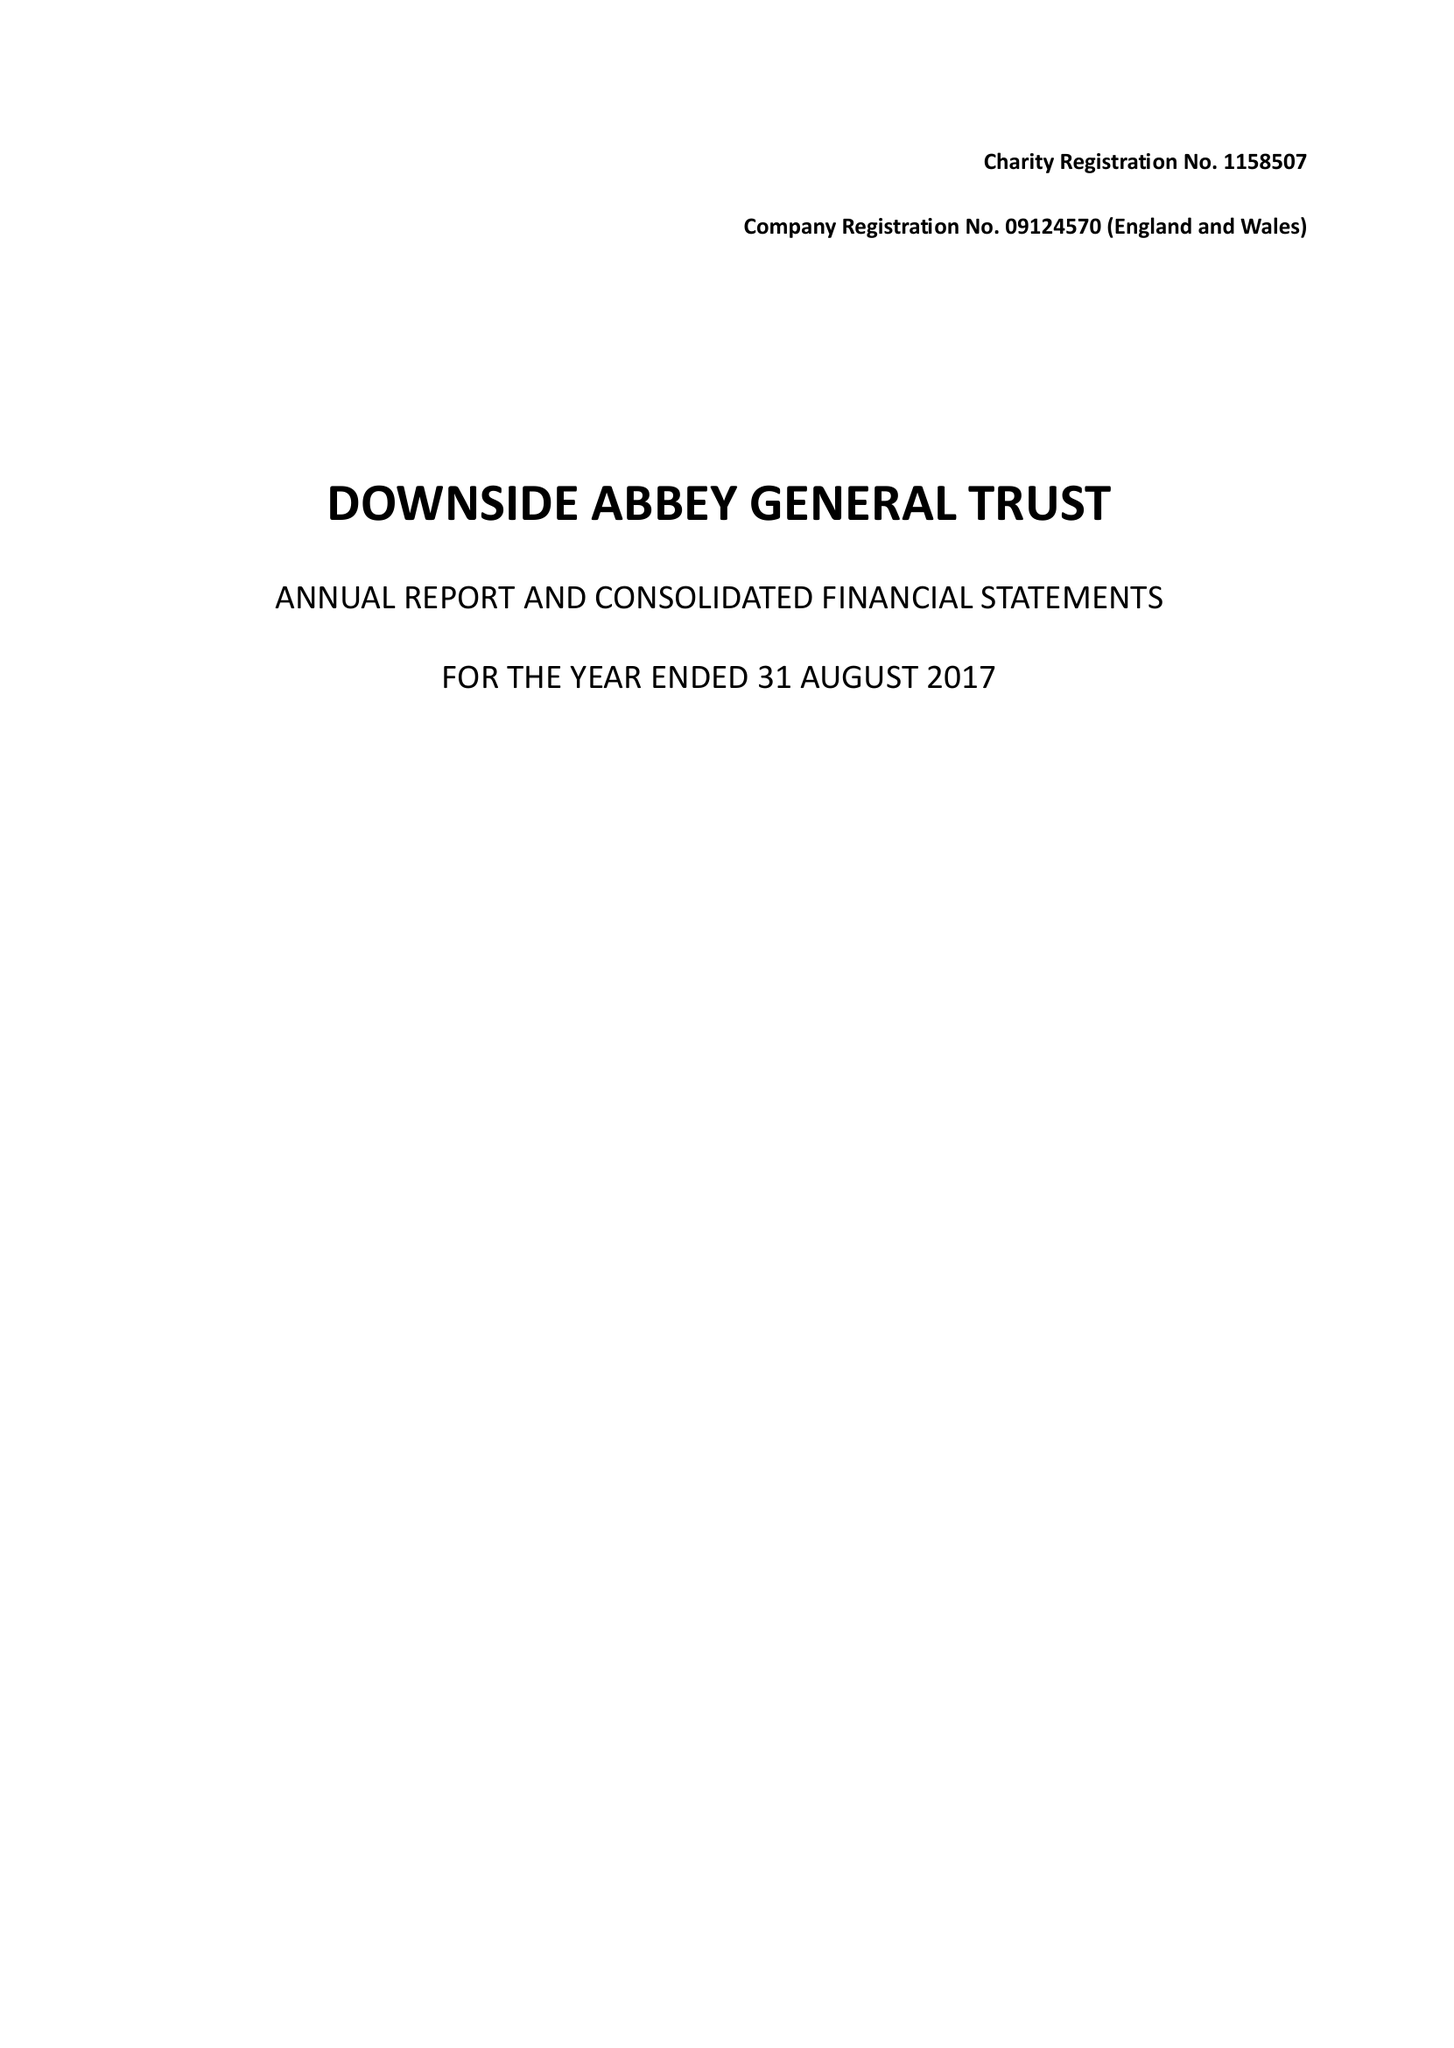What is the value for the charity_name?
Answer the question using a single word or phrase. Downside Abbey General Trust 